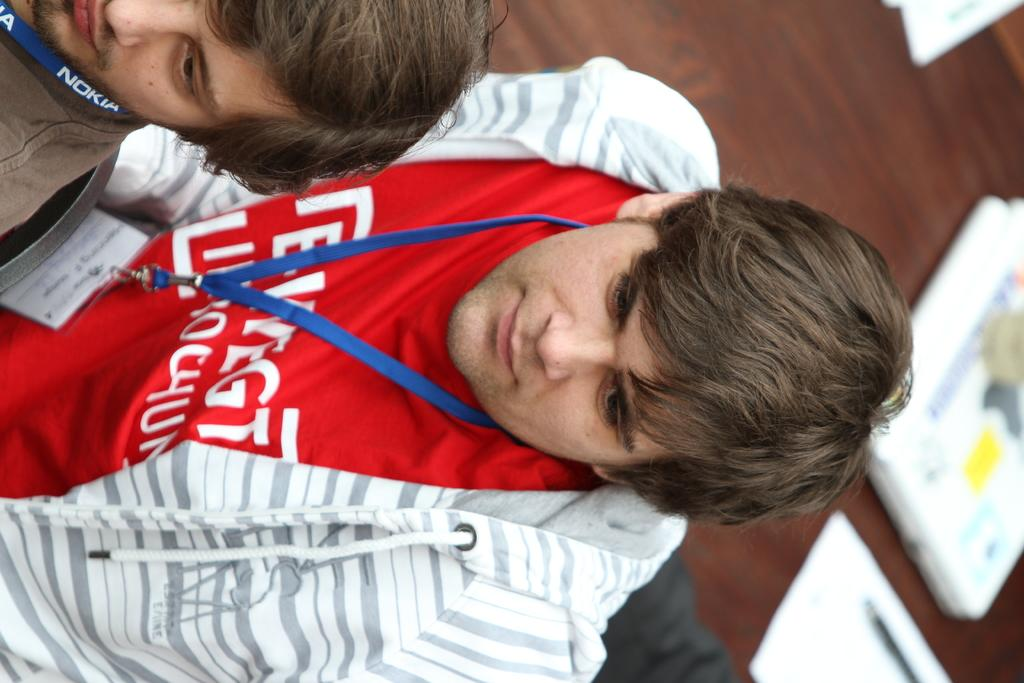<image>
Share a concise interpretation of the image provided. a necklace item that has the name Nokia on it 